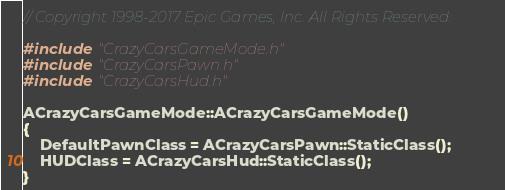<code> <loc_0><loc_0><loc_500><loc_500><_C++_>// Copyright 1998-2017 Epic Games, Inc. All Rights Reserved.

#include "CrazyCarsGameMode.h"
#include "CrazyCarsPawn.h"
#include "CrazyCarsHud.h"

ACrazyCarsGameMode::ACrazyCarsGameMode()
{
	DefaultPawnClass = ACrazyCarsPawn::StaticClass();
	HUDClass = ACrazyCarsHud::StaticClass();
}
</code> 